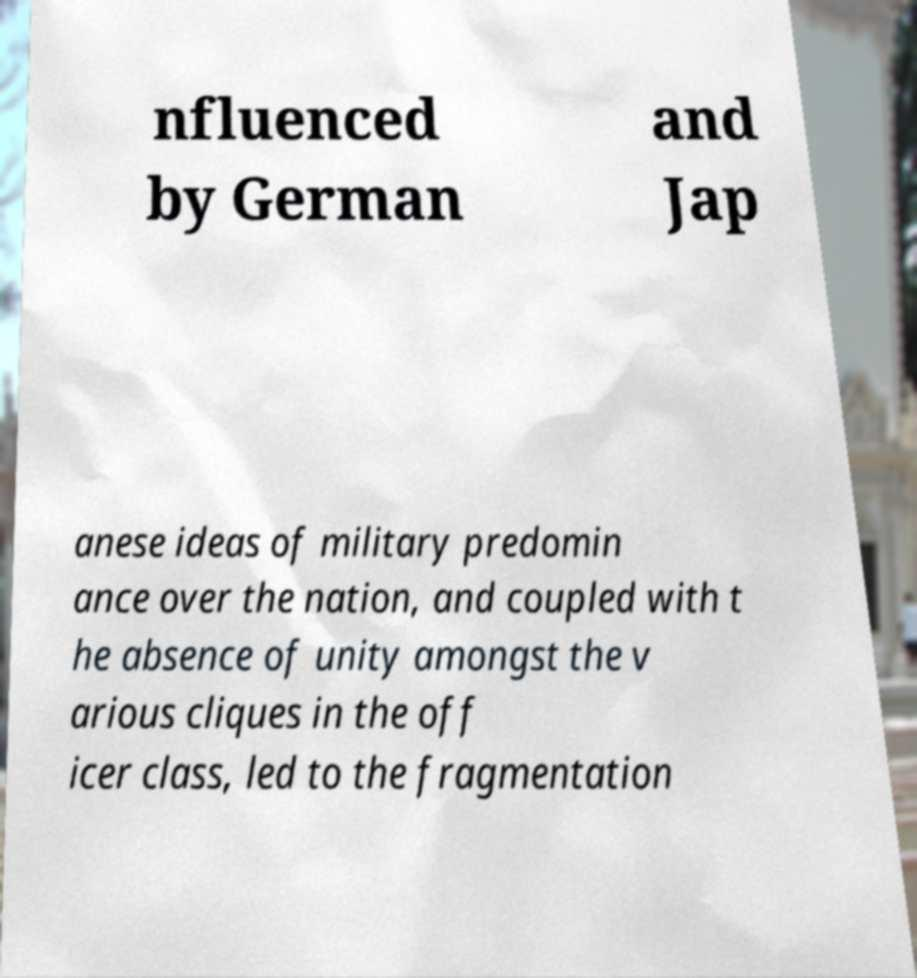Could you assist in decoding the text presented in this image and type it out clearly? nfluenced by German and Jap anese ideas of military predomin ance over the nation, and coupled with t he absence of unity amongst the v arious cliques in the off icer class, led to the fragmentation 